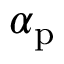Convert formula to latex. <formula><loc_0><loc_0><loc_500><loc_500>\boldsymbol \alpha _ { p }</formula> 